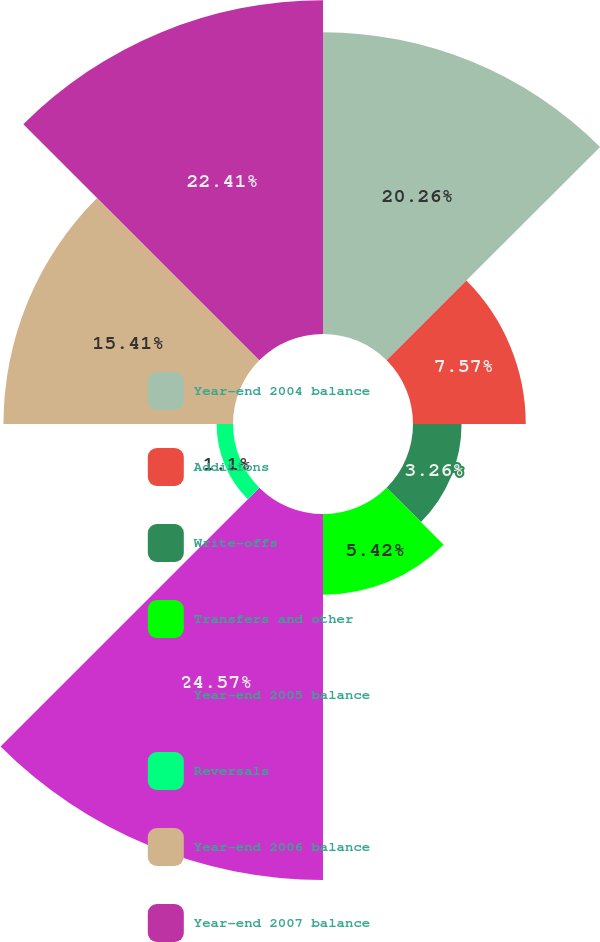Convert chart to OTSL. <chart><loc_0><loc_0><loc_500><loc_500><pie_chart><fcel>Year-end 2004 balance<fcel>Additions<fcel>Write-offs<fcel>Transfers and other<fcel>Year-end 2005 balance<fcel>Reversals<fcel>Year-end 2006 balance<fcel>Year-end 2007 balance<nl><fcel>20.26%<fcel>7.57%<fcel>3.26%<fcel>5.42%<fcel>24.57%<fcel>1.1%<fcel>15.41%<fcel>22.41%<nl></chart> 